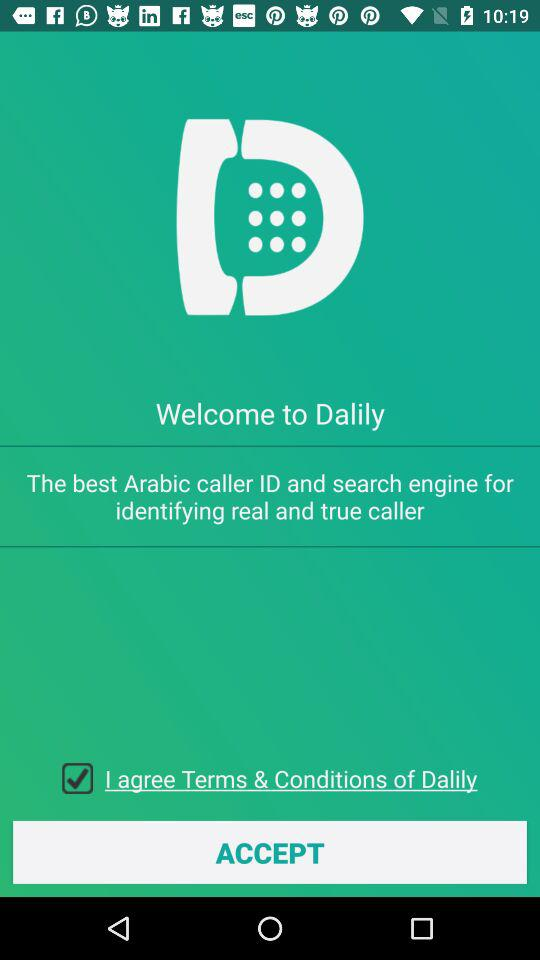What is the status of the option that includes agreement to the "Terms" and "Conditions"? The status is "on". 